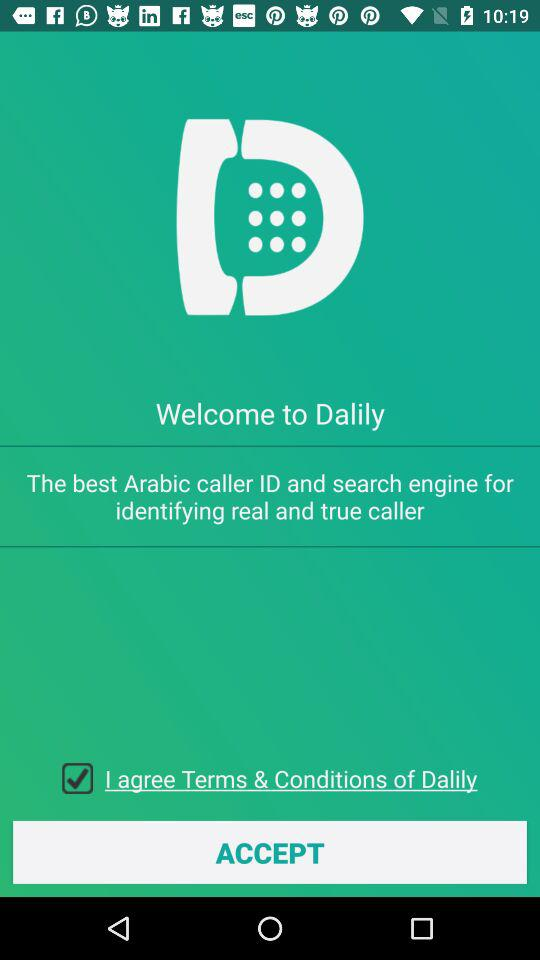What is the status of the option that includes agreement to the "Terms" and "Conditions"? The status is "on". 